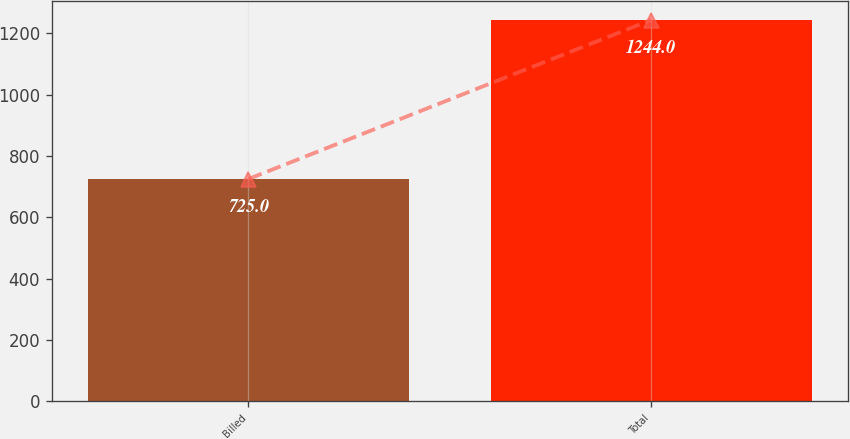Convert chart to OTSL. <chart><loc_0><loc_0><loc_500><loc_500><bar_chart><fcel>Billed<fcel>Total<nl><fcel>725<fcel>1244<nl></chart> 